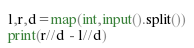Convert code to text. <code><loc_0><loc_0><loc_500><loc_500><_Python_>l,r,d=map(int,input().split())
print(r//d - l//d)</code> 